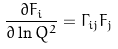<formula> <loc_0><loc_0><loc_500><loc_500>\frac { \partial F _ { i } } { \partial \ln Q ^ { 2 } } = \Gamma _ { i j } F _ { j }</formula> 